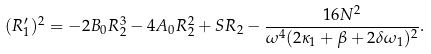<formula> <loc_0><loc_0><loc_500><loc_500>( R _ { 1 } ^ { \prime } ) ^ { 2 } = - 2 B _ { 0 } R _ { 2 } ^ { 3 } - 4 A _ { 0 } R _ { 2 } ^ { 2 } + S R _ { 2 } - \frac { 1 6 N ^ { 2 } } { \omega ^ { 4 } ( 2 \kappa _ { 1 } + \beta + 2 \delta \omega _ { 1 } ) ^ { 2 } } .</formula> 